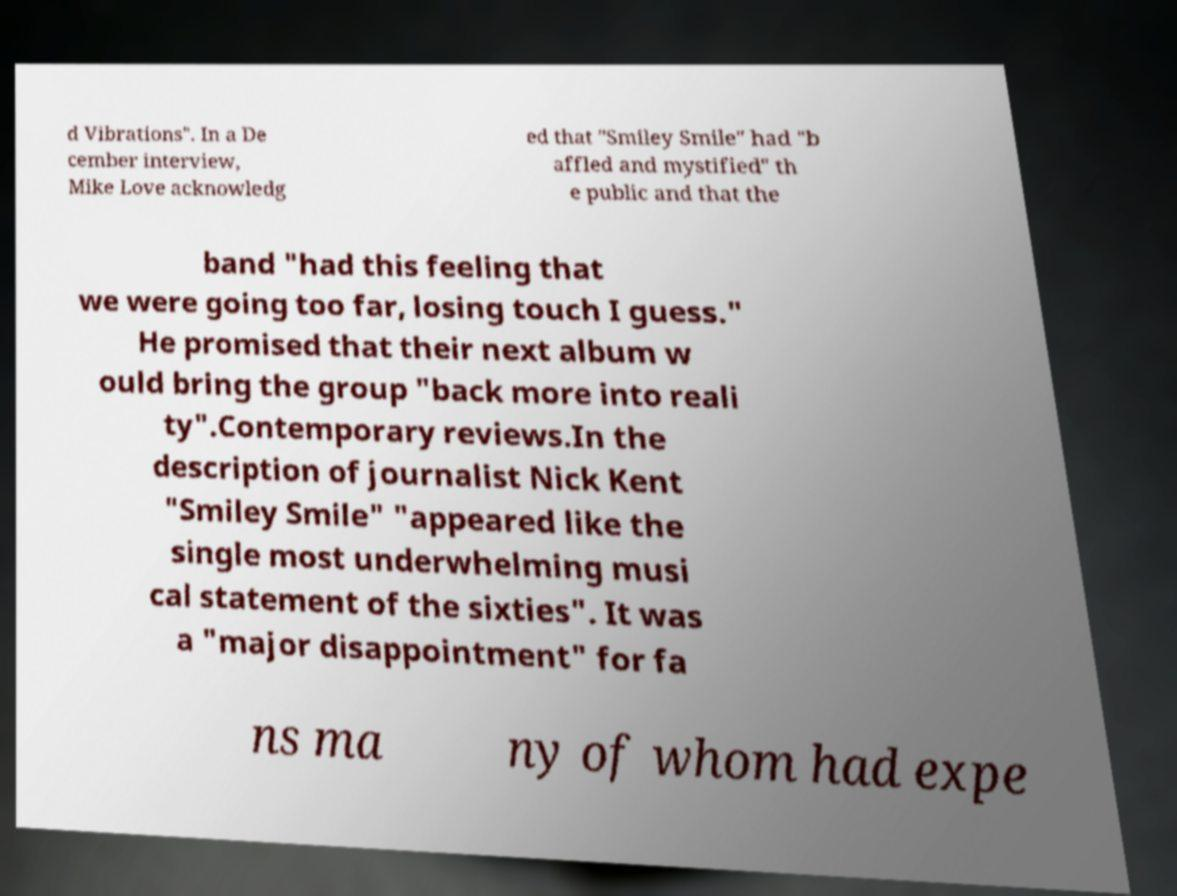I need the written content from this picture converted into text. Can you do that? d Vibrations". In a De cember interview, Mike Love acknowledg ed that "Smiley Smile" had "b affled and mystified" th e public and that the band "had this feeling that we were going too far, losing touch I guess." He promised that their next album w ould bring the group "back more into reali ty".Contemporary reviews.In the description of journalist Nick Kent "Smiley Smile" "appeared like the single most underwhelming musi cal statement of the sixties". It was a "major disappointment" for fa ns ma ny of whom had expe 